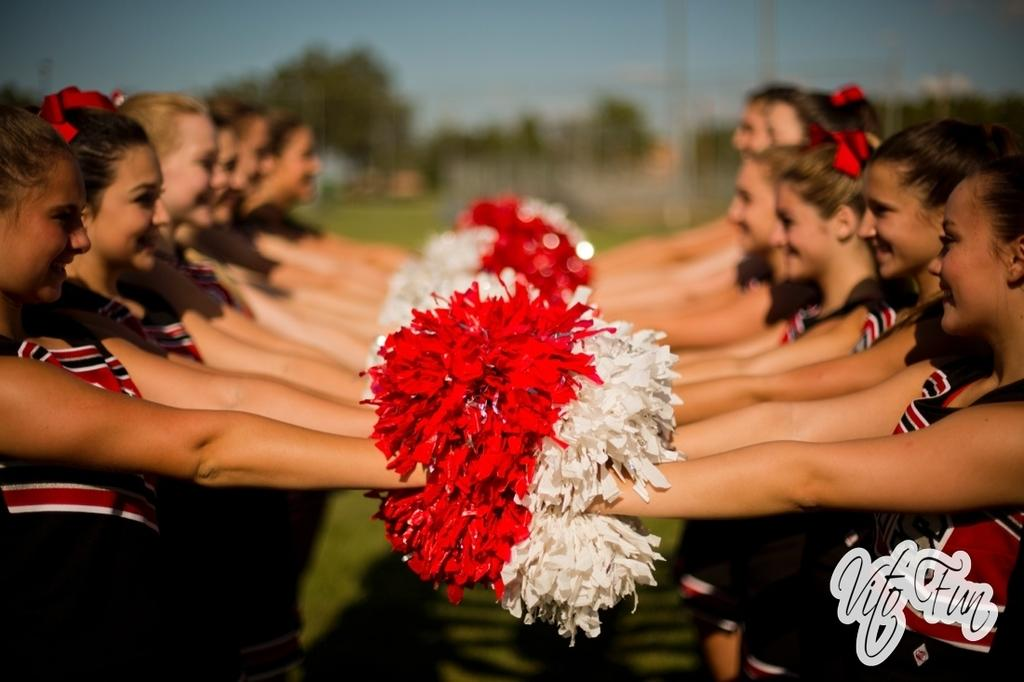What is happening in the image? There are people standing in the image. What are the people holding in their hands? The people are holding objects in their hands. What can be seen in the background of the image? There are trees visible in the image. How would you describe the quality of the background in the image? The background of the image is blurred. What type of club does the actor use in the image? There is no club or actor present in the image. 